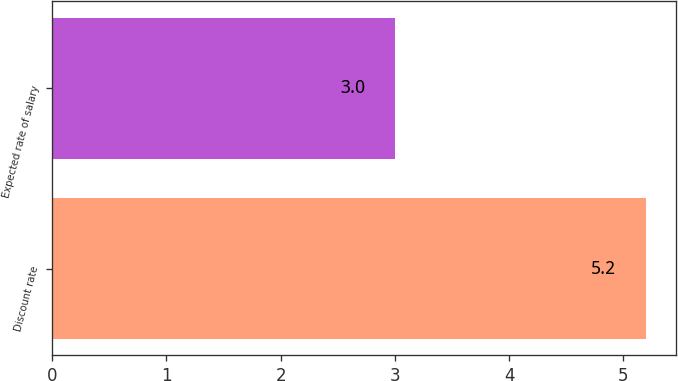Convert chart. <chart><loc_0><loc_0><loc_500><loc_500><bar_chart><fcel>Discount rate<fcel>Expected rate of salary<nl><fcel>5.2<fcel>3<nl></chart> 